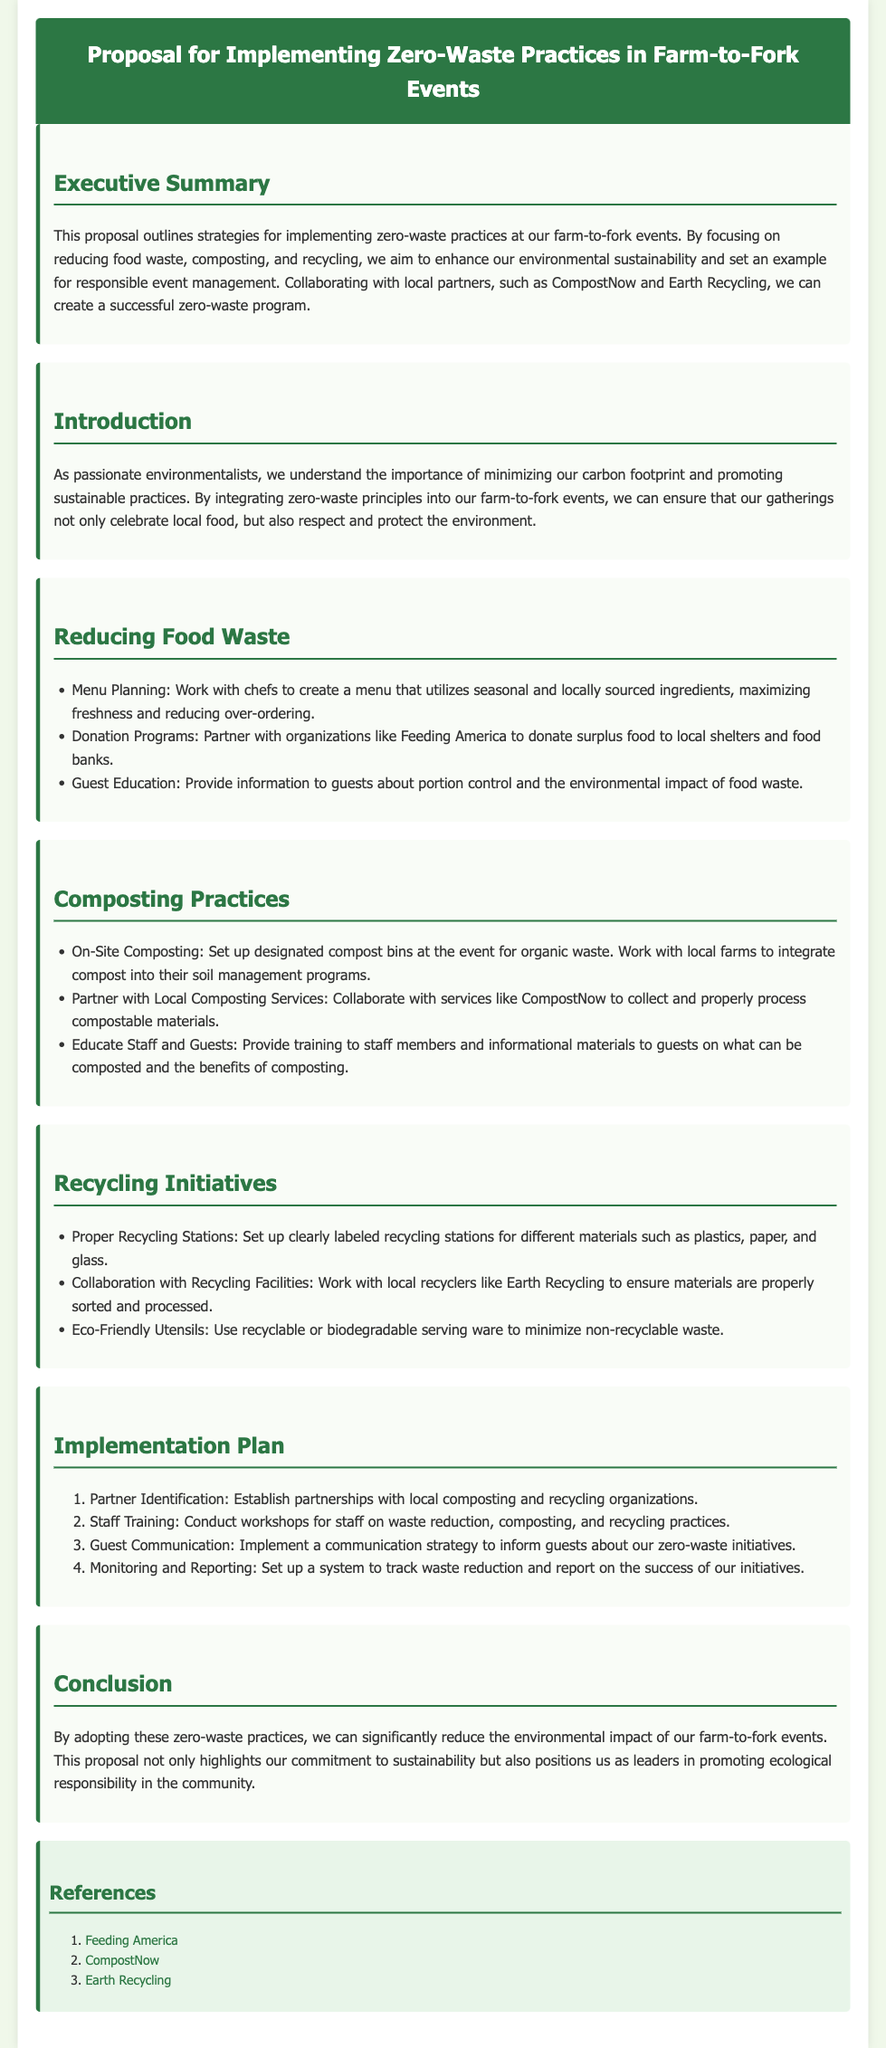What is the title of the proposal? The title provides the subject of the document outlining the strategies for sustainability events.
Answer: Proposal for Implementing Zero-Waste Practices in Farm-to-Fork Events What is one of the strategies mentioned for reducing food waste? The document lists strategies within sections, highlighting specific measures to target food waste.
Answer: Menu Planning What organization is mentioned for food donations? The proposal includes partnerships with organizations to facilitate food donations, enhancing its community impact.
Answer: Feeding America How many steps are in the implementation plan? The document outlines steps in a numbered list for clear process guidance.
Answer: Four What is the main goal of the proposal? The proposal indicates overarching goals that define its purpose and intended outcome for events.
Answer: Enhance environmental sustainability Who are the local partners mentioned for composting? The proposal specifies collaboration with local services to successfully manage composting efforts.
Answer: CompostNow Which practice is suggested to educate guests about waste? The document includes educational aspects to engage attendees about sustainability practices at events.
Answer: Guest Education What color represents the header background? The header’s color provides visual emphasis and consistency throughout the document, aiding in navigation.
Answer: Green What is one benefit of proper recycling mentioned? Recycling initiatives highlight practices aimed at minimizing waste, contributing to a larger environmental goal.
Answer: Reduce non-recyclable waste 